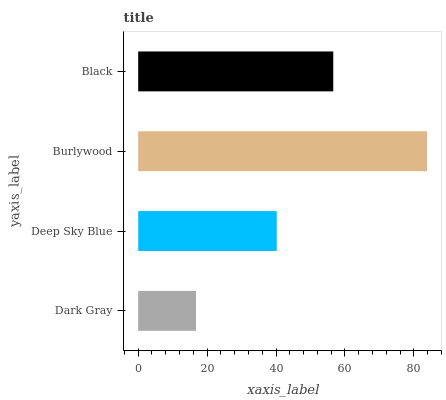Is Dark Gray the minimum?
Answer yes or no. Yes. Is Burlywood the maximum?
Answer yes or no. Yes. Is Deep Sky Blue the minimum?
Answer yes or no. No. Is Deep Sky Blue the maximum?
Answer yes or no. No. Is Deep Sky Blue greater than Dark Gray?
Answer yes or no. Yes. Is Dark Gray less than Deep Sky Blue?
Answer yes or no. Yes. Is Dark Gray greater than Deep Sky Blue?
Answer yes or no. No. Is Deep Sky Blue less than Dark Gray?
Answer yes or no. No. Is Black the high median?
Answer yes or no. Yes. Is Deep Sky Blue the low median?
Answer yes or no. Yes. Is Burlywood the high median?
Answer yes or no. No. Is Burlywood the low median?
Answer yes or no. No. 